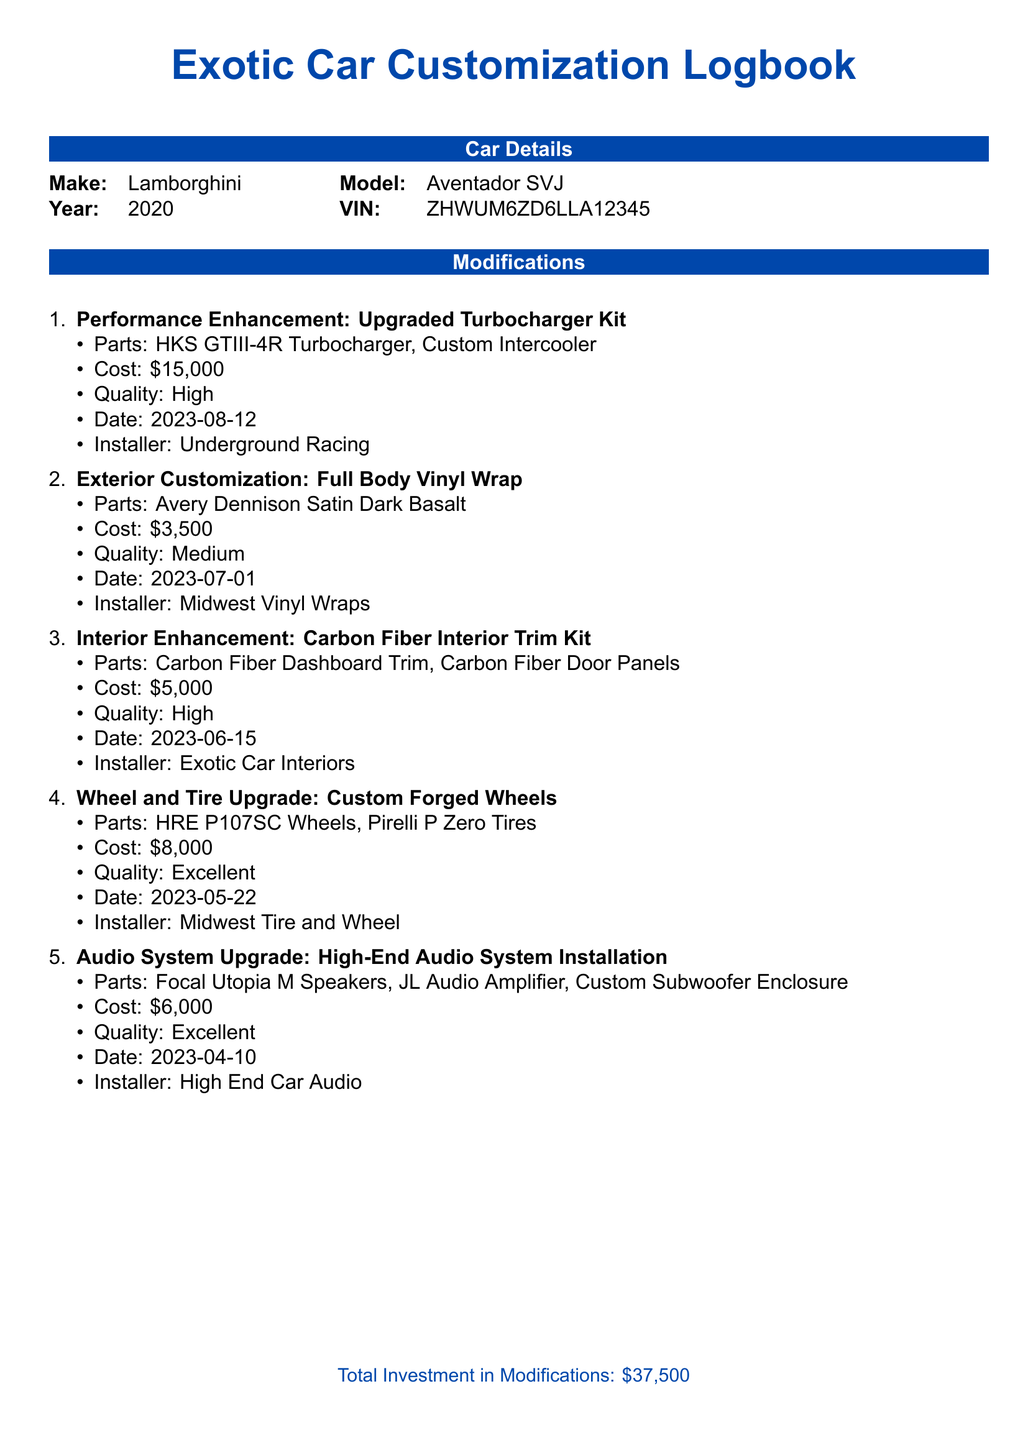What make and model is documented? The make and model of the car can be found in the car details section of the document.
Answer: Lamborghini Aventador SVJ What was the total investment in modifications? The total investment is mentioned at the end of the modifications section.
Answer: $37,500 When was the full body vinyl wrap done? The date of the exterior customization is listed under its specific modification details.
Answer: 2023-07-01 Who installed the upgraded turbocharger kit? The installer for the performance enhancement is specified in the corresponding modification section.
Answer: Underground Racing What is the quality rating for the carbon fiber interior trim kit? The quality of the interior enhancement can be found in the modification details.
Answer: High How much did the custom forged wheels cost? The cost of the wheel and tire upgrade is outlined in the modification items list.
Answer: $8,000 What parts were used in the high-end audio system installation? The parts for the audio system upgrade are specified under its description in the document.
Answer: Focal Utopia M Speakers, JL Audio Amplifier, Custom Subwoofer Enclosure What type of wheels were upgraded? The modification details for the wheel and tire upgrade provide the type of wheels used.
Answer: Custom Forged Wheels What is the installation date for the carbon fiber trim kit? The date of installation for the interior enhancement is included in the modification details.
Answer: 2023-06-15 